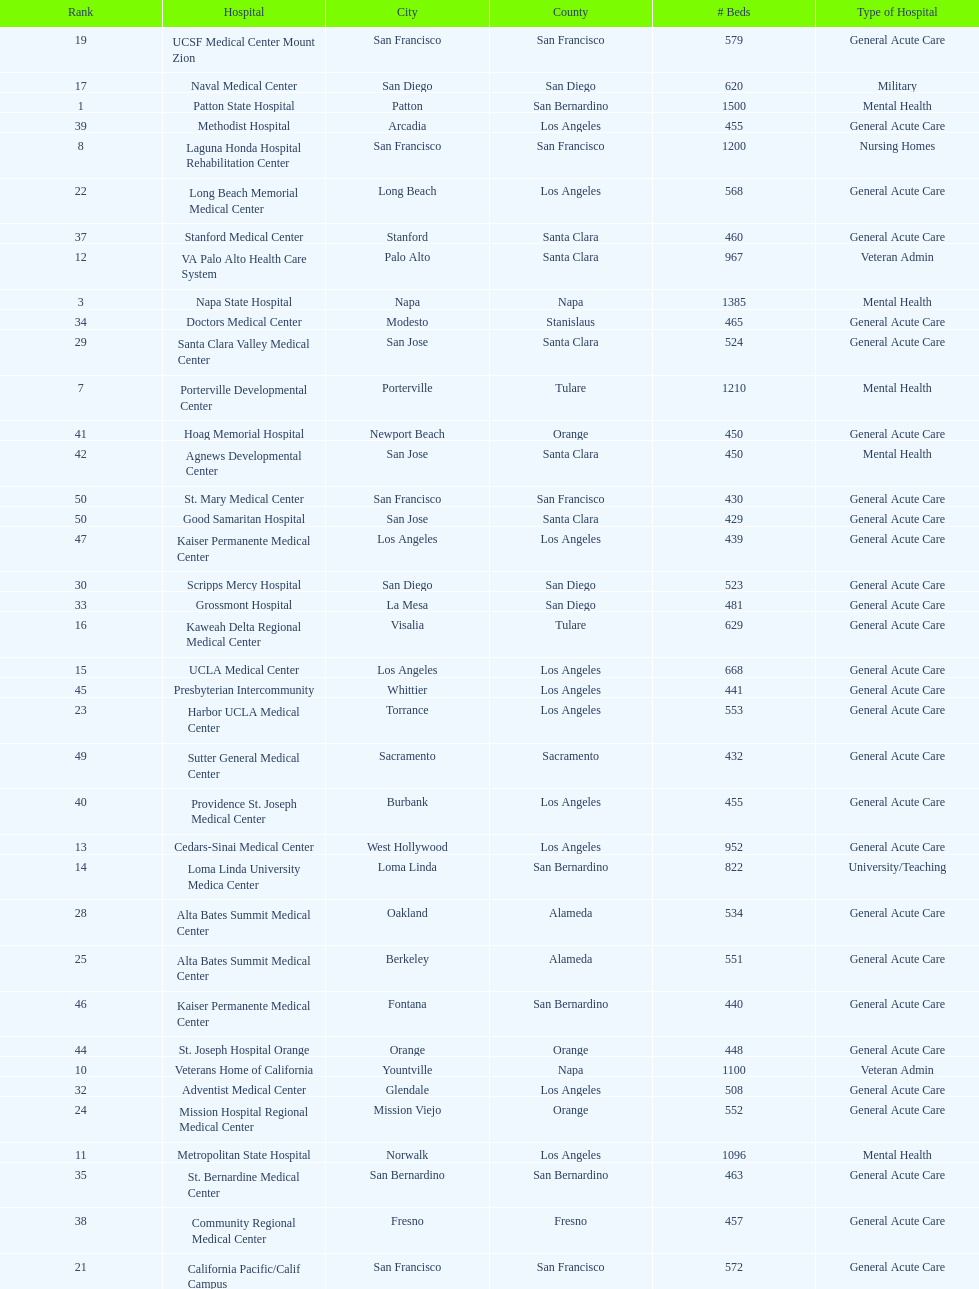I'm looking to parse the entire table for insights. Could you assist me with that? {'header': ['Rank', 'Hospital', 'City', 'County', '# Beds', 'Type of Hospital'], 'rows': [['19', 'UCSF Medical Center Mount Zion', 'San Francisco', 'San Francisco', '579', 'General Acute Care'], ['17', 'Naval Medical Center', 'San Diego', 'San Diego', '620', 'Military'], ['1', 'Patton State Hospital', 'Patton', 'San Bernardino', '1500', 'Mental Health'], ['39', 'Methodist Hospital', 'Arcadia', 'Los Angeles', '455', 'General Acute Care'], ['8', 'Laguna Honda Hospital Rehabilitation Center', 'San Francisco', 'San Francisco', '1200', 'Nursing Homes'], ['22', 'Long Beach Memorial Medical Center', 'Long Beach', 'Los Angeles', '568', 'General Acute Care'], ['37', 'Stanford Medical Center', 'Stanford', 'Santa Clara', '460', 'General Acute Care'], ['12', 'VA Palo Alto Health Care System', 'Palo Alto', 'Santa Clara', '967', 'Veteran Admin'], ['3', 'Napa State Hospital', 'Napa', 'Napa', '1385', 'Mental Health'], ['34', 'Doctors Medical Center', 'Modesto', 'Stanislaus', '465', 'General Acute Care'], ['29', 'Santa Clara Valley Medical Center', 'San Jose', 'Santa Clara', '524', 'General Acute Care'], ['7', 'Porterville Developmental Center', 'Porterville', 'Tulare', '1210', 'Mental Health'], ['41', 'Hoag Memorial Hospital', 'Newport Beach', 'Orange', '450', 'General Acute Care'], ['42', 'Agnews Developmental Center', 'San Jose', 'Santa Clara', '450', 'Mental Health'], ['50', 'St. Mary Medical Center', 'San Francisco', 'San Francisco', '430', 'General Acute Care'], ['50', 'Good Samaritan Hospital', 'San Jose', 'Santa Clara', '429', 'General Acute Care'], ['47', 'Kaiser Permanente Medical Center', 'Los Angeles', 'Los Angeles', '439', 'General Acute Care'], ['30', 'Scripps Mercy Hospital', 'San Diego', 'San Diego', '523', 'General Acute Care'], ['33', 'Grossmont Hospital', 'La Mesa', 'San Diego', '481', 'General Acute Care'], ['16', 'Kaweah Delta Regional Medical Center', 'Visalia', 'Tulare', '629', 'General Acute Care'], ['15', 'UCLA Medical Center', 'Los Angeles', 'Los Angeles', '668', 'General Acute Care'], ['45', 'Presbyterian Intercommunity', 'Whittier', 'Los Angeles', '441', 'General Acute Care'], ['23', 'Harbor UCLA Medical Center', 'Torrance', 'Los Angeles', '553', 'General Acute Care'], ['49', 'Sutter General Medical Center', 'Sacramento', 'Sacramento', '432', 'General Acute Care'], ['40', 'Providence St. Joseph Medical Center', 'Burbank', 'Los Angeles', '455', 'General Acute Care'], ['13', 'Cedars-Sinai Medical Center', 'West Hollywood', 'Los Angeles', '952', 'General Acute Care'], ['14', 'Loma Linda University Medica Center', 'Loma Linda', 'San Bernardino', '822', 'University/Teaching'], ['28', 'Alta Bates Summit Medical Center', 'Oakland', 'Alameda', '534', 'General Acute Care'], ['25', 'Alta Bates Summit Medical Center', 'Berkeley', 'Alameda', '551', 'General Acute Care'], ['46', 'Kaiser Permanente Medical Center', 'Fontana', 'San Bernardino', '440', 'General Acute Care'], ['44', 'St. Joseph Hospital Orange', 'Orange', 'Orange', '448', 'General Acute Care'], ['10', 'Veterans Home of California', 'Yountville', 'Napa', '1100', 'Veteran Admin'], ['32', 'Adventist Medical Center', 'Glendale', 'Los Angeles', '508', 'General Acute Care'], ['24', 'Mission Hospital Regional Medical Center', 'Mission Viejo', 'Orange', '552', 'General Acute Care'], ['11', 'Metropolitan State Hospital', 'Norwalk', 'Los Angeles', '1096', 'Mental Health'], ['35', 'St. Bernardine Medical Center', 'San Bernardino', 'San Bernardino', '463', 'General Acute Care'], ['38', 'Community Regional Medical Center', 'Fresno', 'Fresno', '457', 'General Acute Care'], ['21', 'California Pacific/Calif Campus', 'San Francisco', 'San Francisco', '572', 'General Acute Care'], ['9', 'Atascadero State Hospital', 'Atascadero', 'San Luis Obispo', '1200', 'Mental Health'], ['27', 'UCSF Medical Center at Parnassus', 'San Francisco', 'San Francisco', '536', 'General Acute Care'], ['4', 'Sonoma Developmental Center', 'Eldridge', 'Sonoma', '1300', 'Mental Health'], ['43', 'Jewish Home', 'San Francisco', 'San Francisco', '450', 'Nursing Homes'], ['48', 'Pomona Valley Hospital Medical Center', 'Pomona', 'Los Angeles', '436', 'General Acute Care'], ['36', 'UCI Medical Center', 'Orange', 'Orange', '462', 'General Acute Care'], ['26', 'San Francisco General Hospital', 'San Francisco', 'San Francisco', '550', 'General Acute Care'], ['31', 'Huntington Memorial Hospital', 'Pasadena', 'Los Angeles', '522', 'General Acute Care'], ['6', 'Fairview Developmental Center', 'Costa Mesa', 'Orange', '1218', 'Mental Health'], ['2', 'LA County & USC Medical Center', 'Los Angeles', 'Los Angeles', '1395', 'General Acute Care'], ['5', 'Lanterman Developmental Center', 'Pomona', 'Los Angeles', '1286', 'Rehabilitaion'], ['20', 'UCD Medical Center', 'Sacramento', 'Sacramento', '577', 'University/Teaching'], ['18', 'UCSD Medical Center', 'San Diego', 'San Diego', '594', 'University/Teaching']]} How much larger (in number of beds) was the largest hospital in california than the 50th largest? 1071. 